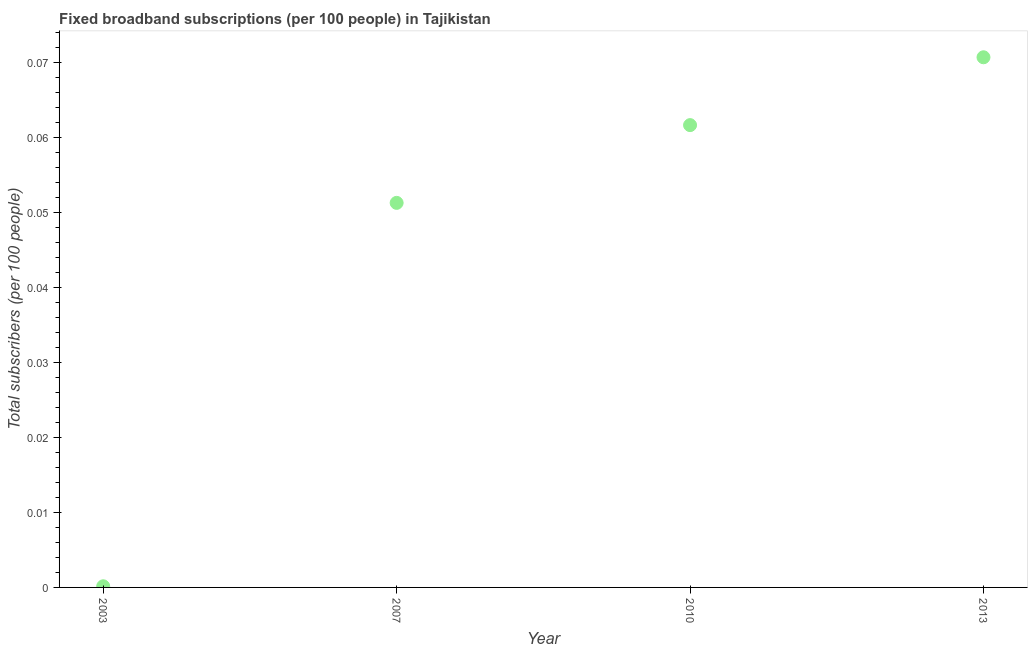What is the total number of fixed broadband subscriptions in 2003?
Your response must be concise. 0. Across all years, what is the maximum total number of fixed broadband subscriptions?
Provide a short and direct response. 0.07. Across all years, what is the minimum total number of fixed broadband subscriptions?
Give a very brief answer. 0. In which year was the total number of fixed broadband subscriptions maximum?
Provide a succinct answer. 2013. In which year was the total number of fixed broadband subscriptions minimum?
Keep it short and to the point. 2003. What is the sum of the total number of fixed broadband subscriptions?
Offer a very short reply. 0.18. What is the difference between the total number of fixed broadband subscriptions in 2003 and 2013?
Provide a succinct answer. -0.07. What is the average total number of fixed broadband subscriptions per year?
Ensure brevity in your answer.  0.05. What is the median total number of fixed broadband subscriptions?
Your answer should be very brief. 0.06. What is the ratio of the total number of fixed broadband subscriptions in 2003 to that in 2010?
Offer a very short reply. 0. Is the difference between the total number of fixed broadband subscriptions in 2007 and 2013 greater than the difference between any two years?
Give a very brief answer. No. What is the difference between the highest and the second highest total number of fixed broadband subscriptions?
Ensure brevity in your answer.  0.01. What is the difference between the highest and the lowest total number of fixed broadband subscriptions?
Your response must be concise. 0.07. In how many years, is the total number of fixed broadband subscriptions greater than the average total number of fixed broadband subscriptions taken over all years?
Offer a terse response. 3. How many dotlines are there?
Offer a terse response. 1. How many years are there in the graph?
Offer a very short reply. 4. Does the graph contain any zero values?
Provide a short and direct response. No. What is the title of the graph?
Offer a terse response. Fixed broadband subscriptions (per 100 people) in Tajikistan. What is the label or title of the Y-axis?
Your answer should be compact. Total subscribers (per 100 people). What is the Total subscribers (per 100 people) in 2003?
Ensure brevity in your answer.  0. What is the Total subscribers (per 100 people) in 2007?
Make the answer very short. 0.05. What is the Total subscribers (per 100 people) in 2010?
Provide a succinct answer. 0.06. What is the Total subscribers (per 100 people) in 2013?
Your response must be concise. 0.07. What is the difference between the Total subscribers (per 100 people) in 2003 and 2007?
Your response must be concise. -0.05. What is the difference between the Total subscribers (per 100 people) in 2003 and 2010?
Your answer should be very brief. -0.06. What is the difference between the Total subscribers (per 100 people) in 2003 and 2013?
Your response must be concise. -0.07. What is the difference between the Total subscribers (per 100 people) in 2007 and 2010?
Give a very brief answer. -0.01. What is the difference between the Total subscribers (per 100 people) in 2007 and 2013?
Provide a succinct answer. -0.02. What is the difference between the Total subscribers (per 100 people) in 2010 and 2013?
Give a very brief answer. -0.01. What is the ratio of the Total subscribers (per 100 people) in 2003 to that in 2007?
Provide a succinct answer. 0. What is the ratio of the Total subscribers (per 100 people) in 2003 to that in 2010?
Ensure brevity in your answer.  0. What is the ratio of the Total subscribers (per 100 people) in 2003 to that in 2013?
Ensure brevity in your answer.  0. What is the ratio of the Total subscribers (per 100 people) in 2007 to that in 2010?
Offer a terse response. 0.83. What is the ratio of the Total subscribers (per 100 people) in 2007 to that in 2013?
Keep it short and to the point. 0.72. What is the ratio of the Total subscribers (per 100 people) in 2010 to that in 2013?
Your answer should be compact. 0.87. 